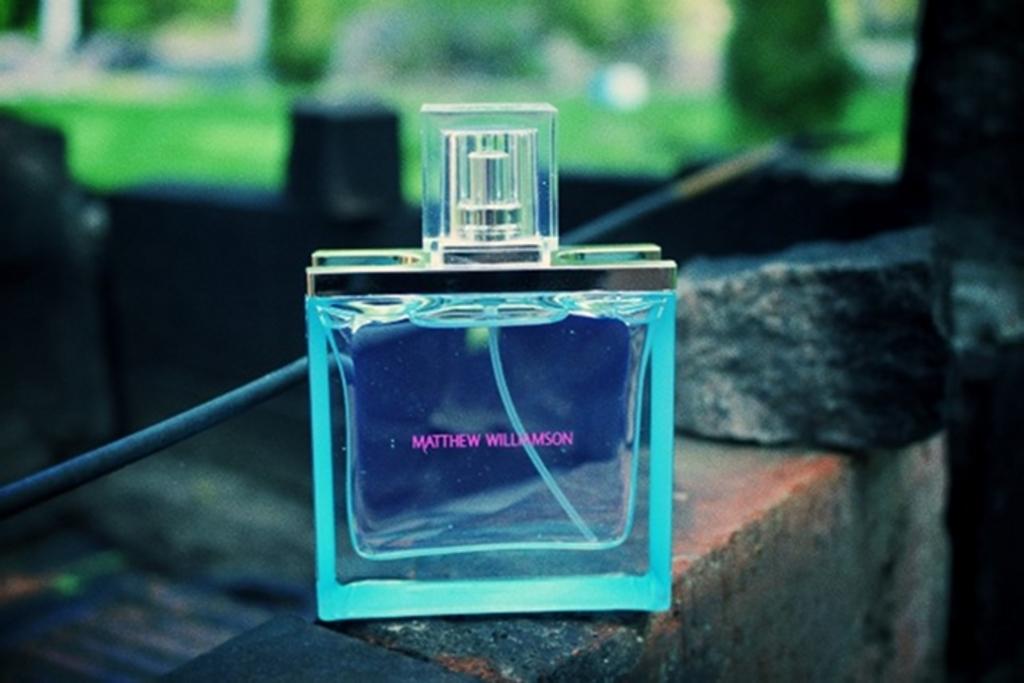Is this by matthew willamson?
Give a very brief answer. Yes. Who is the brand on this product?
Offer a terse response. Matthew williamson. 